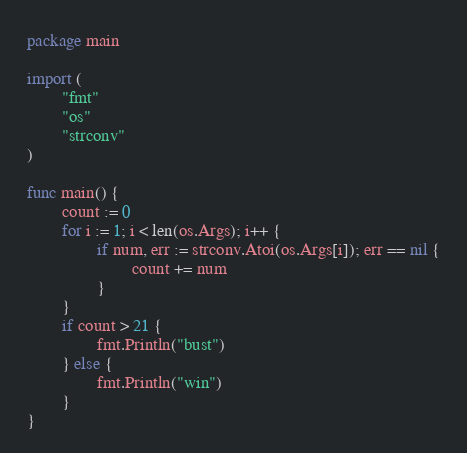<code> <loc_0><loc_0><loc_500><loc_500><_Go_>package main

import (
        "fmt"
        "os"
        "strconv"
)

func main() {
        count := 0
        for i := 1; i < len(os.Args); i++ {
                if num, err := strconv.Atoi(os.Args[i]); err == nil {
                        count += num
                }
        }
        if count > 21 {
                fmt.Println("bust")
        } else {
                fmt.Println("win")
        }
}</code> 